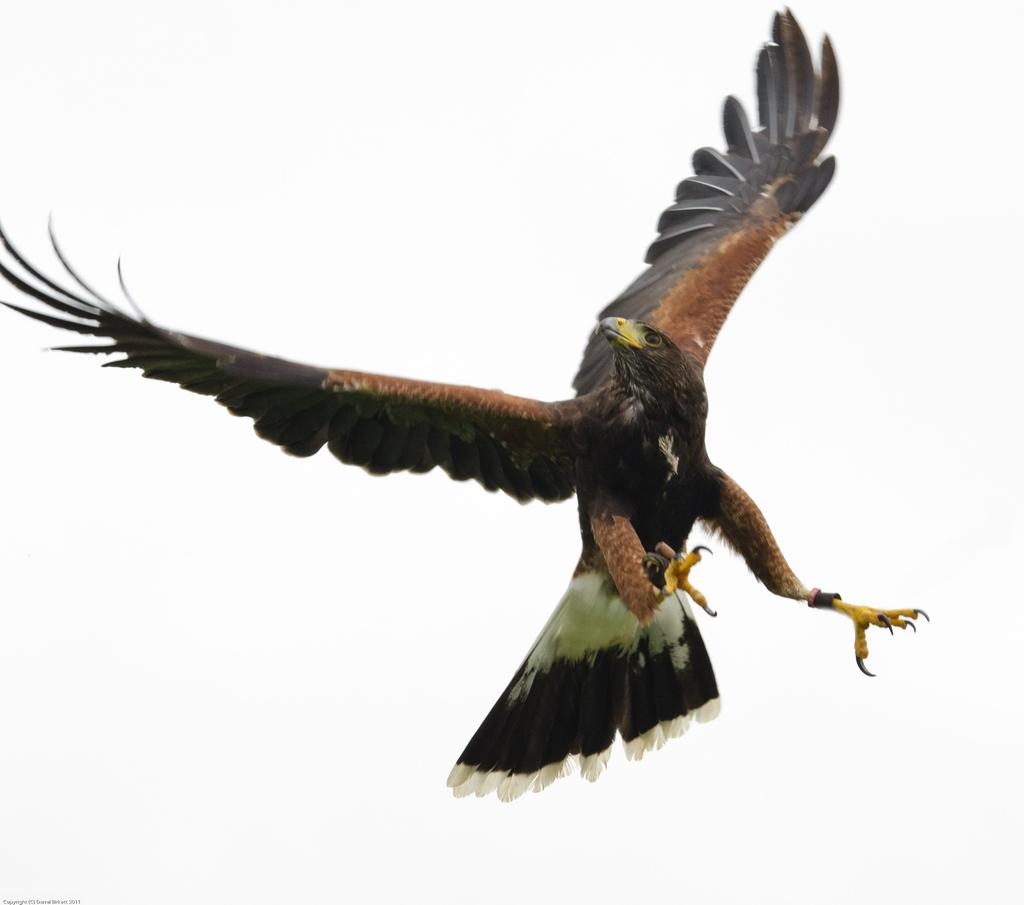What is the main subject of the image? The main subject of the image is a bird flying in the air. What can be observed about the bird's location in the image? The bird is flying in the air. What is the color of the background in the image? The background of the image is white in color. What type of rhythm can be heard from the bird in the image? There is no sound or rhythm associated with the bird in the image; it is a still image of a bird flying in the air. 